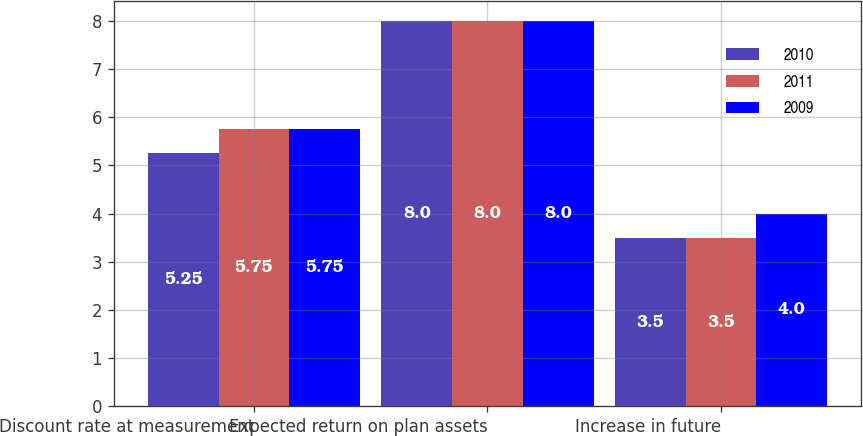<chart> <loc_0><loc_0><loc_500><loc_500><stacked_bar_chart><ecel><fcel>Discount rate at measurement<fcel>Expected return on plan assets<fcel>Increase in future<nl><fcel>2010<fcel>5.25<fcel>8<fcel>3.5<nl><fcel>2011<fcel>5.75<fcel>8<fcel>3.5<nl><fcel>2009<fcel>5.75<fcel>8<fcel>4<nl></chart> 